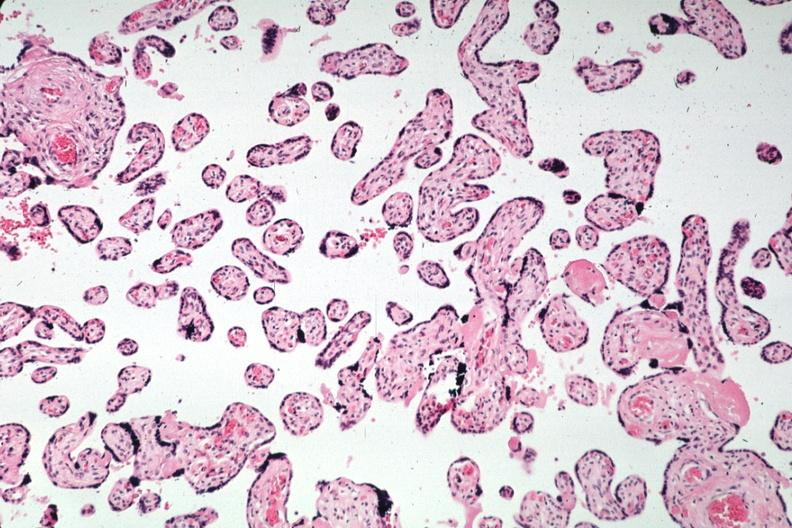what is present?
Answer the question using a single word or phrase. Placenta 